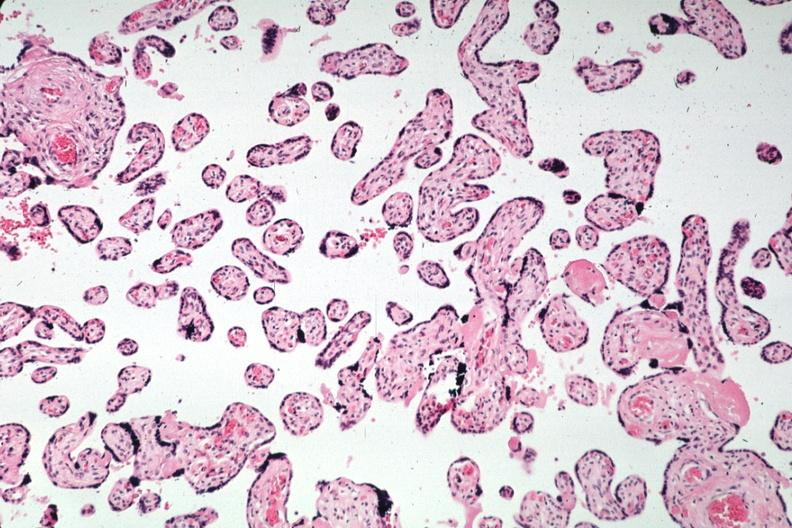what is present?
Answer the question using a single word or phrase. Placenta 